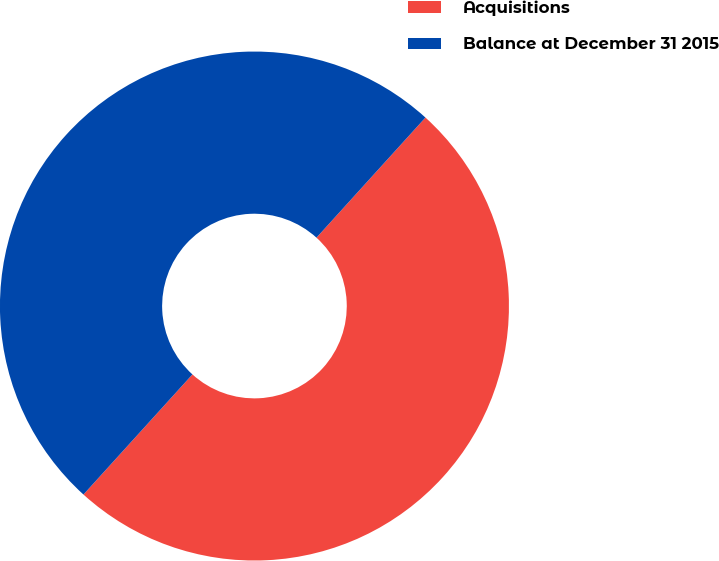Convert chart. <chart><loc_0><loc_0><loc_500><loc_500><pie_chart><fcel>Acquisitions<fcel>Balance at December 31 2015<nl><fcel>50.0%<fcel>50.0%<nl></chart> 